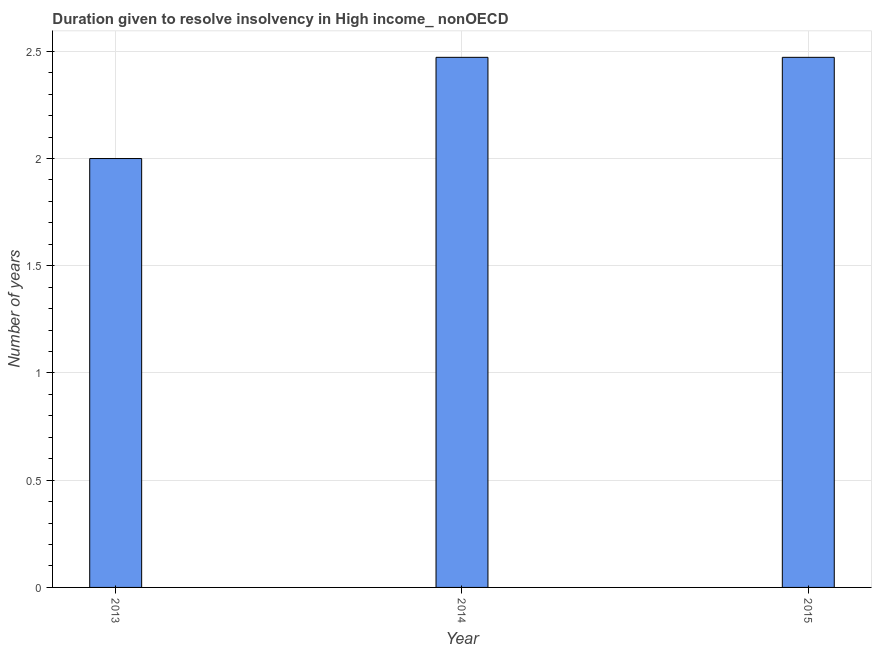What is the title of the graph?
Your answer should be very brief. Duration given to resolve insolvency in High income_ nonOECD. What is the label or title of the X-axis?
Offer a very short reply. Year. What is the label or title of the Y-axis?
Offer a terse response. Number of years. Across all years, what is the maximum number of years to resolve insolvency?
Your answer should be very brief. 2.47. Across all years, what is the minimum number of years to resolve insolvency?
Ensure brevity in your answer.  2. In which year was the number of years to resolve insolvency maximum?
Make the answer very short. 2014. What is the sum of the number of years to resolve insolvency?
Ensure brevity in your answer.  6.94. What is the difference between the number of years to resolve insolvency in 2014 and 2015?
Your answer should be compact. 0. What is the average number of years to resolve insolvency per year?
Ensure brevity in your answer.  2.31. What is the median number of years to resolve insolvency?
Your answer should be very brief. 2.47. What is the ratio of the number of years to resolve insolvency in 2013 to that in 2015?
Offer a very short reply. 0.81. Is the number of years to resolve insolvency in 2013 less than that in 2014?
Offer a terse response. Yes. Is the difference between the number of years to resolve insolvency in 2014 and 2015 greater than the difference between any two years?
Your response must be concise. No. What is the difference between the highest and the second highest number of years to resolve insolvency?
Offer a very short reply. 0. What is the difference between the highest and the lowest number of years to resolve insolvency?
Offer a very short reply. 0.47. In how many years, is the number of years to resolve insolvency greater than the average number of years to resolve insolvency taken over all years?
Offer a terse response. 2. Are the values on the major ticks of Y-axis written in scientific E-notation?
Your answer should be compact. No. What is the Number of years of 2014?
Offer a very short reply. 2.47. What is the Number of years of 2015?
Offer a very short reply. 2.47. What is the difference between the Number of years in 2013 and 2014?
Provide a short and direct response. -0.47. What is the difference between the Number of years in 2013 and 2015?
Make the answer very short. -0.47. What is the ratio of the Number of years in 2013 to that in 2014?
Keep it short and to the point. 0.81. What is the ratio of the Number of years in 2013 to that in 2015?
Give a very brief answer. 0.81. What is the ratio of the Number of years in 2014 to that in 2015?
Provide a succinct answer. 1. 